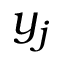<formula> <loc_0><loc_0><loc_500><loc_500>y _ { j }</formula> 